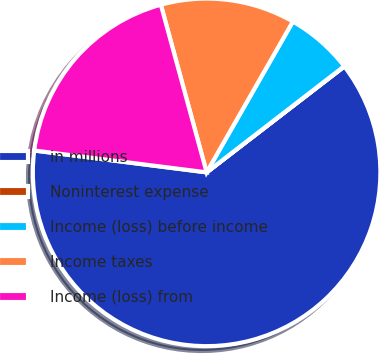Convert chart. <chart><loc_0><loc_0><loc_500><loc_500><pie_chart><fcel>in millions<fcel>Noninterest expense<fcel>Income (loss) before income<fcel>Income taxes<fcel>Income (loss) from<nl><fcel>62.43%<fcel>0.03%<fcel>6.27%<fcel>12.51%<fcel>18.75%<nl></chart> 